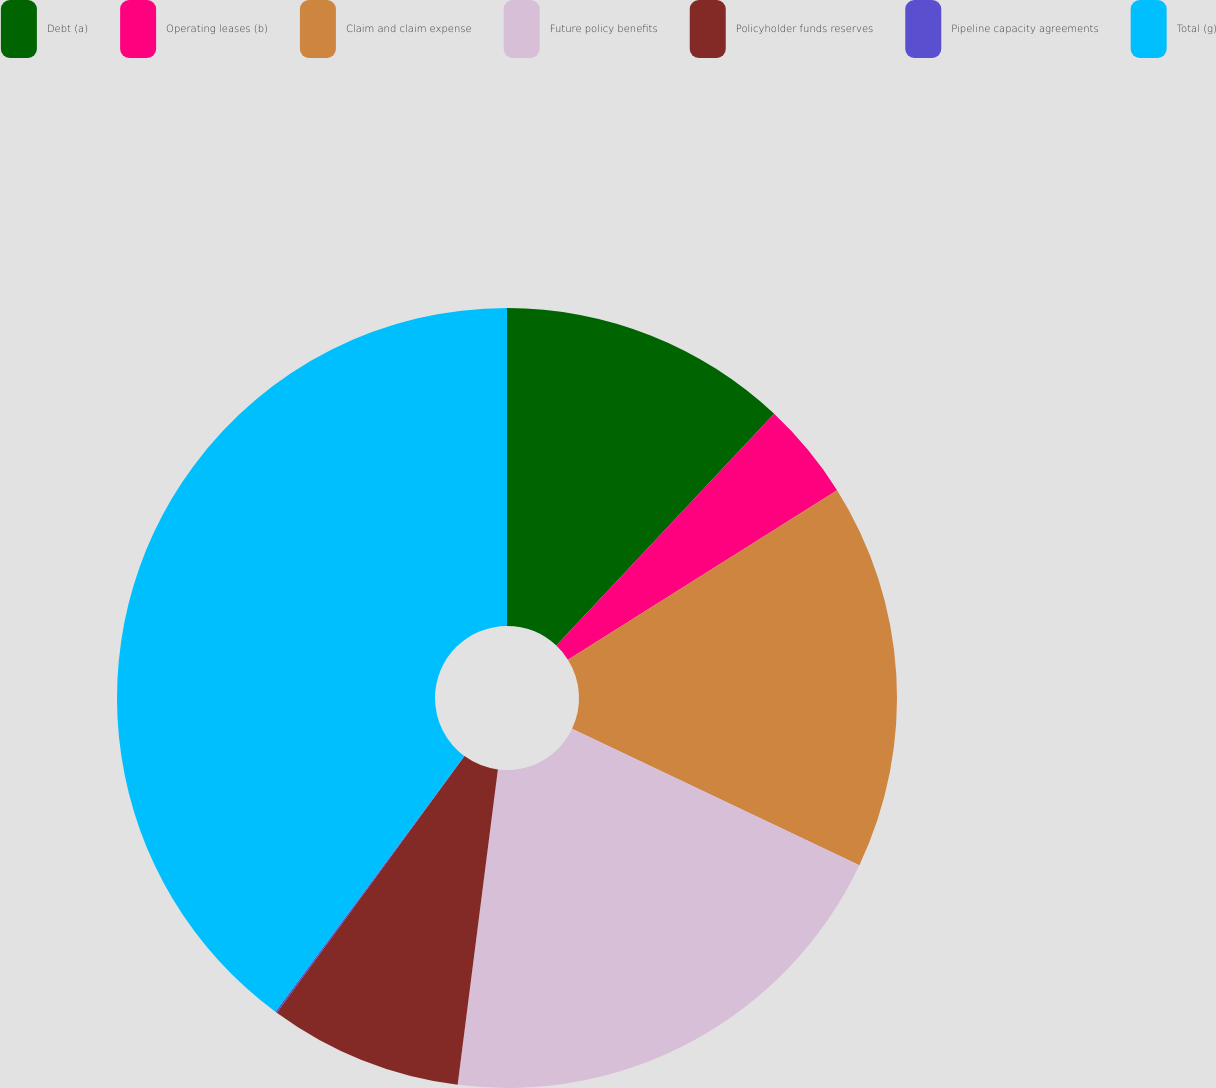<chart> <loc_0><loc_0><loc_500><loc_500><pie_chart><fcel>Debt (a)<fcel>Operating leases (b)<fcel>Claim and claim expense<fcel>Future policy benefits<fcel>Policyholder funds reserves<fcel>Pipeline capacity agreements<fcel>Total (g)<nl><fcel>12.01%<fcel>4.05%<fcel>15.99%<fcel>19.97%<fcel>8.03%<fcel>0.07%<fcel>39.88%<nl></chart> 